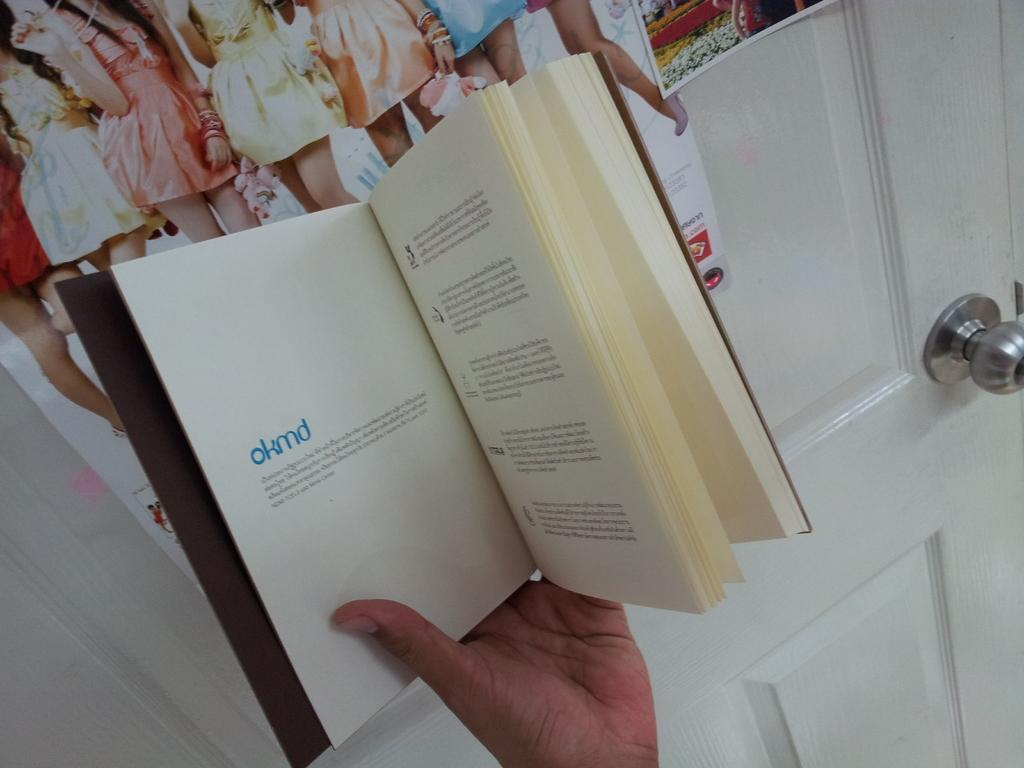<image>
Provide a brief description of the given image. A book is open to a page with the heading okmd. 